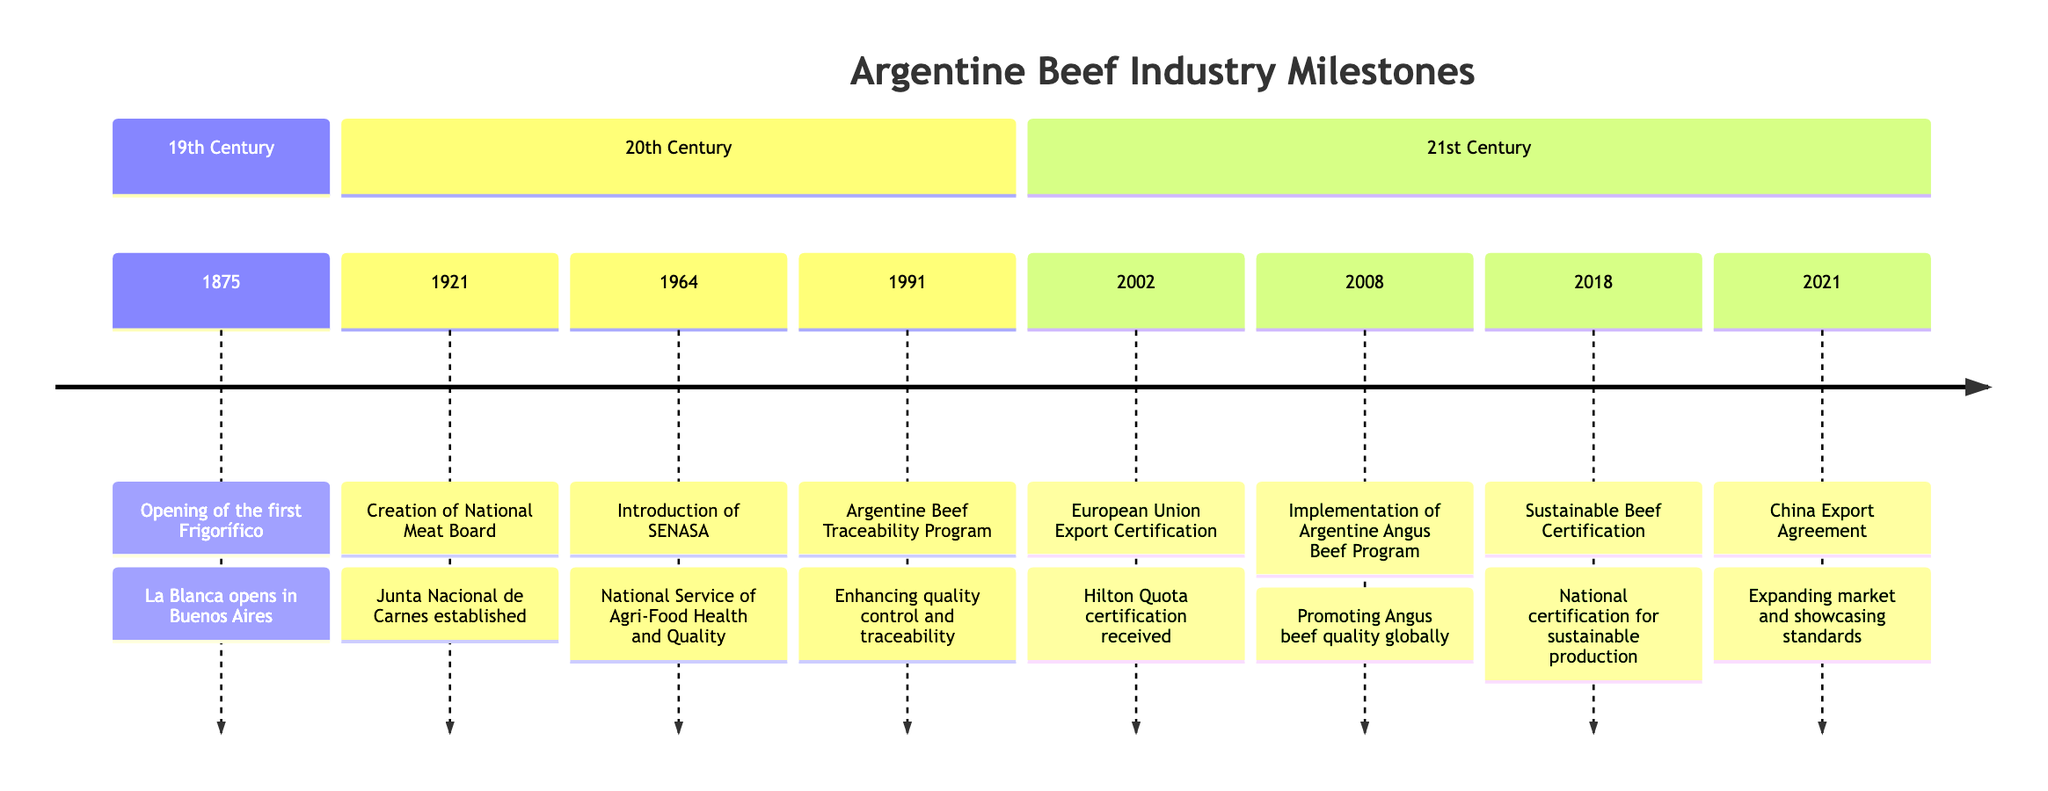What year did the first Frigorífico open? The diagram shows that the first Frigorífico opened in 1875. This is found in the first section of the timeline labeled "19th Century."
Answer: 1875 What organization was created in 1921? According to the diagram, the National Meat Board (Junta Nacional de Carnes) was established in 1921, as indicated in the "20th Century" section.
Answer: National Meat Board How many significant events are listed in the 21st Century? The timeline contains four key events listed under the "21st Century" section, which include the European Union Export Certification, Argentine Angus Beef Program, Sustainable Beef Certification, and China Export Agreement.
Answer: 4 What program was launched in 1991? The diagram specifies that in 1991, the Argentine Beef Traceability Program was launched. This information is detailed in the "20th Century" section.
Answer: Argentine Beef Traceability Program What certification did Argentina receive in 2002? The diagram reveals that in 2002, Argentina received the European Union Export Certification under the Hilton Quota. This is recorded in the "21st Century" part of the timeline.
Answer: European Union Export Certification What major market expansion occurred in 2021? The diagram indicates that in 2021, Argentina signed a significant beef export agreement with China, showing a major market expansion. This is a pivotal event mentioned in the "21st Century" section.
Answer: China Export Agreement How many decades separate the establishment of SENASA and the Argentine Beef Traceability Program? SENASA was introduced in 1964 and the Argentine Beef Traceability Program was launched in 1991. There are 27 years between 1964 and 1991, which represents over two decades.
Answer: 2 decades What does the Argentine Angus Beef Program promote? According to the diagram, the Argentine Angus Beef Program promotes the superior quality of Angus beef. This information is found in the event from 2008 in the "21st Century" section.
Answer: Angus beef quality What year marks the introduction of sustainable beef certification? The diagram states that sustainable beef certification was introduced in 2018, as noted in the "21st Century" section.
Answer: 2018 